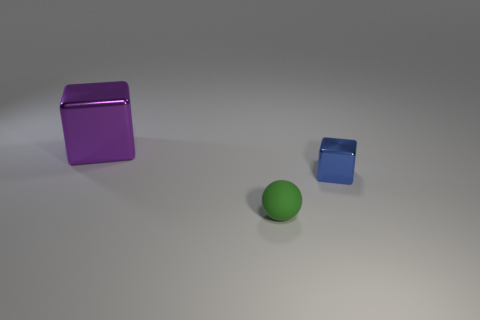Subtract all purple cubes. How many cubes are left? 1 Subtract 1 blocks. How many blocks are left? 1 Add 2 purple things. How many objects exist? 5 Subtract all balls. How many objects are left? 2 Add 3 metallic blocks. How many metallic blocks are left? 5 Add 2 tiny rubber balls. How many tiny rubber balls exist? 3 Subtract 0 brown cylinders. How many objects are left? 3 Subtract all brown blocks. Subtract all green balls. How many blocks are left? 2 Subtract all big gray rubber blocks. Subtract all green rubber spheres. How many objects are left? 2 